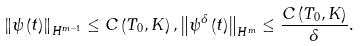Convert formula to latex. <formula><loc_0><loc_0><loc_500><loc_500>\left \| \psi \left ( t \right ) \right \| _ { H ^ { m - 1 } } \leq C \left ( T _ { 0 } , K \right ) , \left \| \psi ^ { \delta } \left ( t \right ) \right \| _ { H ^ { m } } \leq \frac { C \left ( T _ { 0 } , K \right ) } { \delta } .</formula> 